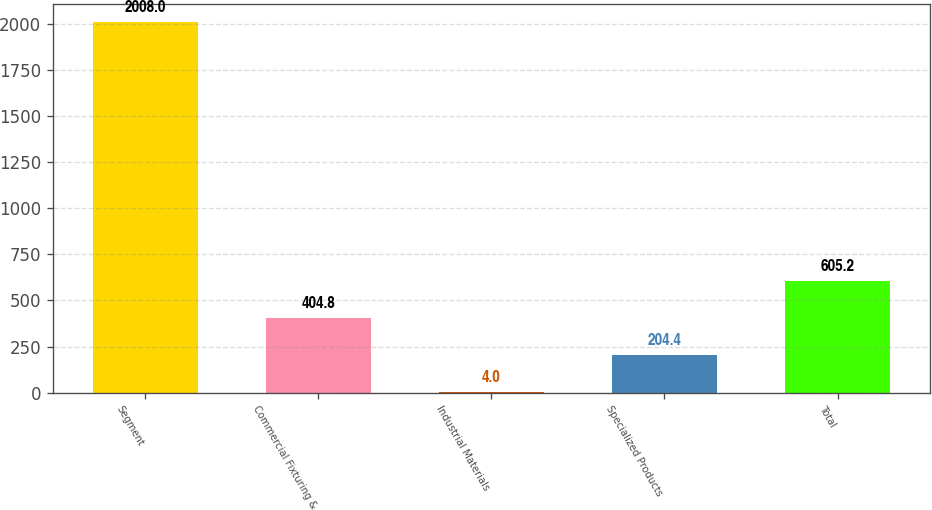Convert chart to OTSL. <chart><loc_0><loc_0><loc_500><loc_500><bar_chart><fcel>Segment<fcel>Commercial Fixturing &<fcel>Industrial Materials<fcel>Specialized Products<fcel>Total<nl><fcel>2008<fcel>404.8<fcel>4<fcel>204.4<fcel>605.2<nl></chart> 